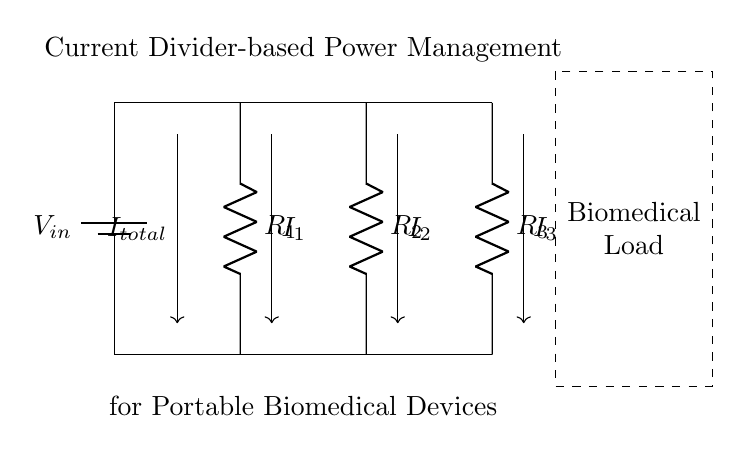What is the input voltage in the circuit? The input voltage, represented as V_in, is the voltage supplied by the battery in the circuit and is placed at the top.
Answer: V_in What are the resistors used in the circuit? The resistors identified in the circuit diagram are R_1, R_2, and R_3, each connected in parallel with each other.
Answer: R_1, R_2, R_3 What direction does the total current flow? The total current, indicated as I_total, flows downward from the top to the bottom of the circuit through the battery and the resistors.
Answer: Downward How is the total current divided among the resistors? The total current I_total is divided into three parts I_1, I_2, and I_3 according to the value of resistors, reflecting the current divider principle where current inversely relates to resistance.
Answer: According to resistance values What is the significance of the dashed rectangle? The dashed rectangle denotes the area that represents a biomedical load, indicating the purpose of the circuit is to power portable biomedical devices.
Answer: Biomedical load What happens to the current if R_1 is removed? If R_1 is removed, the total current I_total will split between R_2 and R_3 only, potentially increasing the current through R_2 and R_3 depending on their resistances.
Answer: Increases through R_2 and R_3 